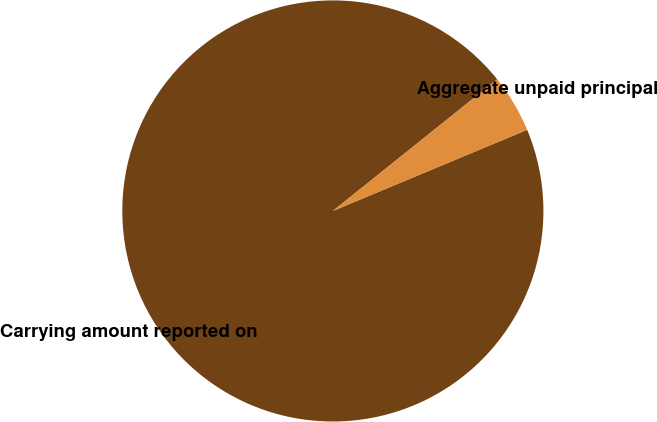Convert chart to OTSL. <chart><loc_0><loc_0><loc_500><loc_500><pie_chart><fcel>Carrying amount reported on<fcel>Aggregate unpaid principal<nl><fcel>95.55%<fcel>4.45%<nl></chart> 